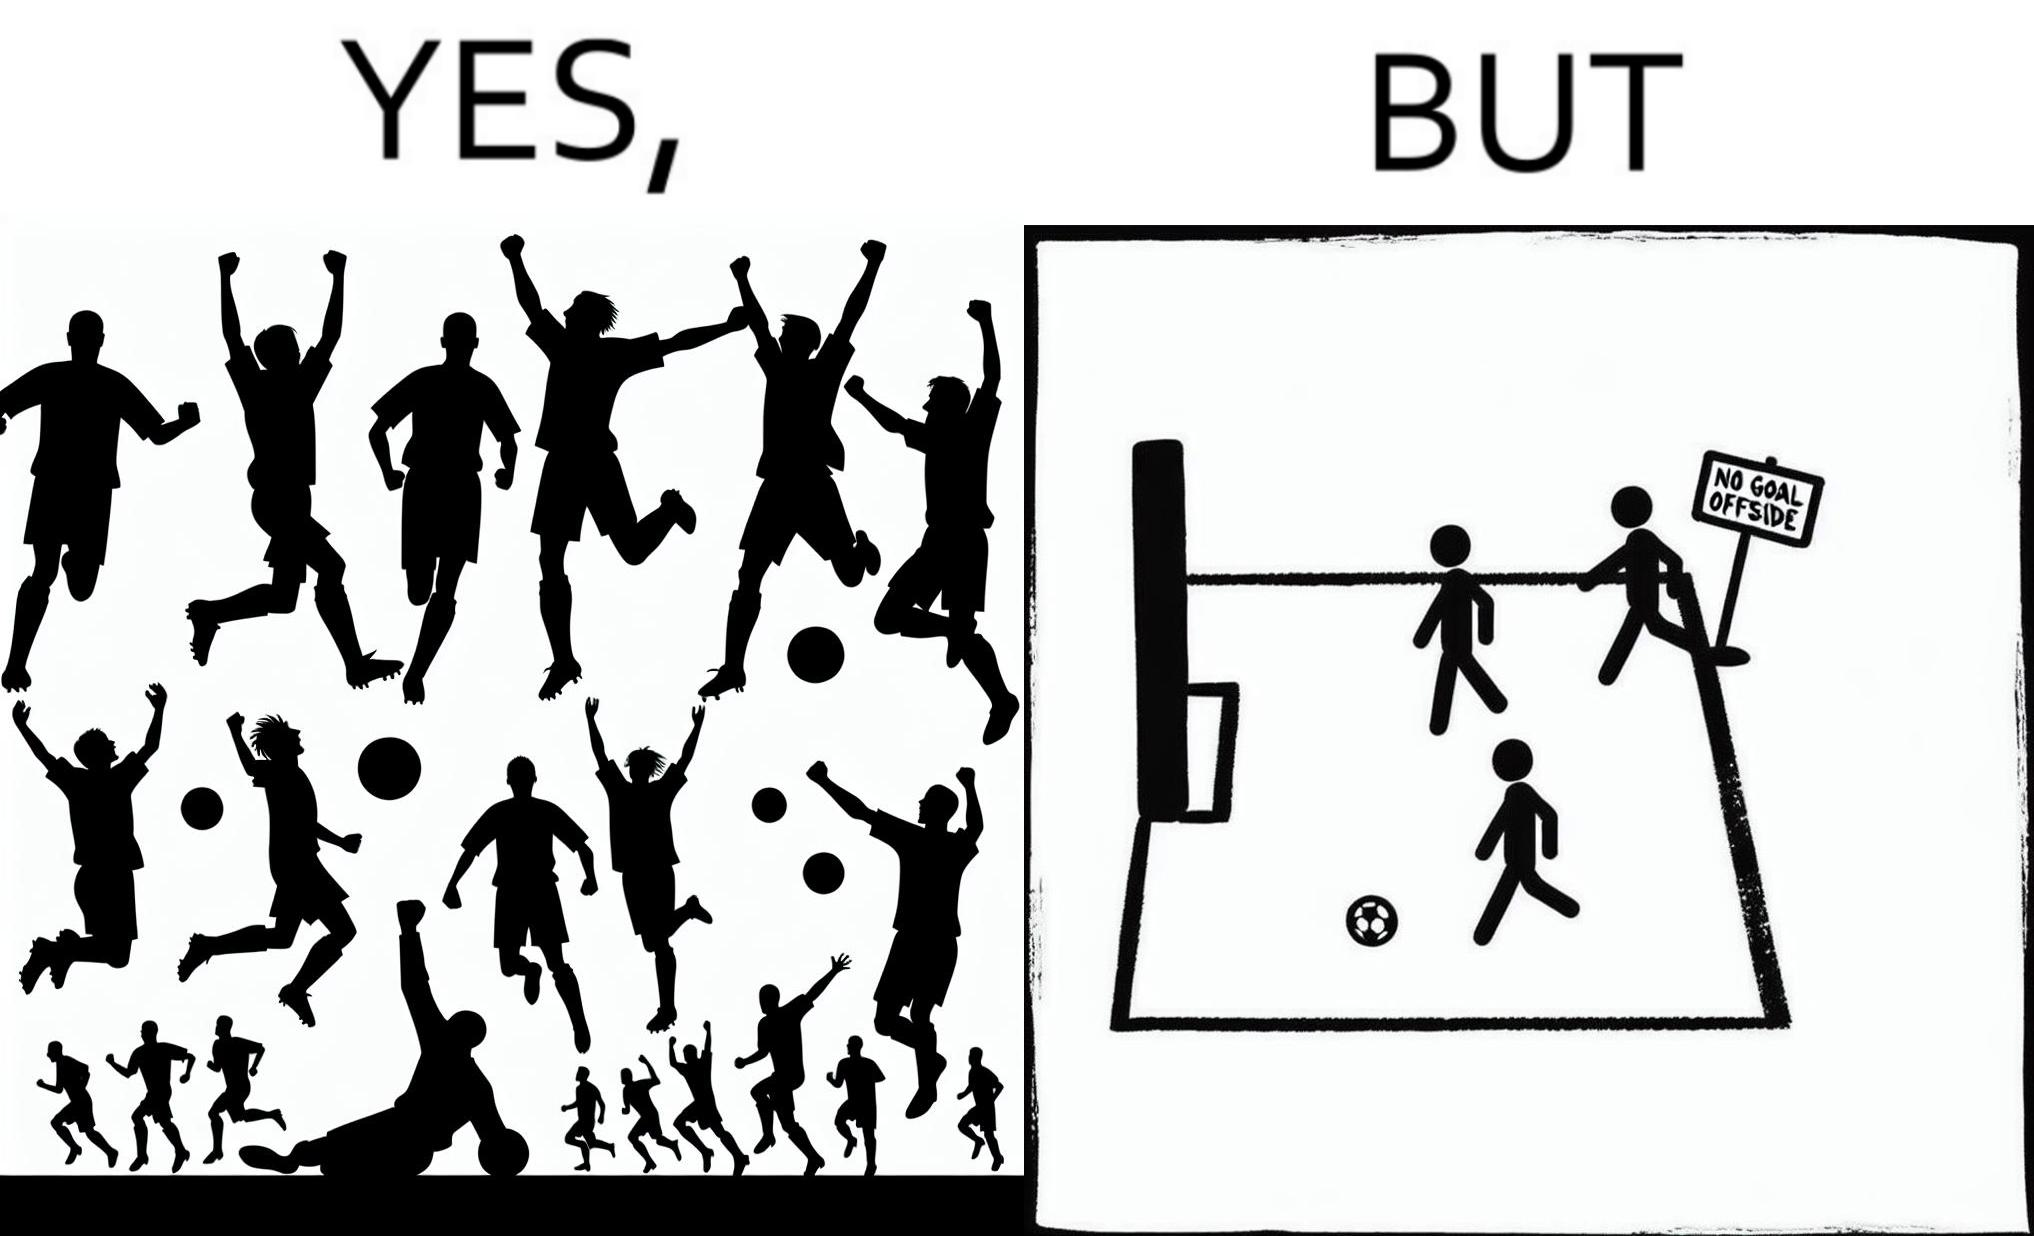Is there satirical content in this image? Yes, this image is satirical. 